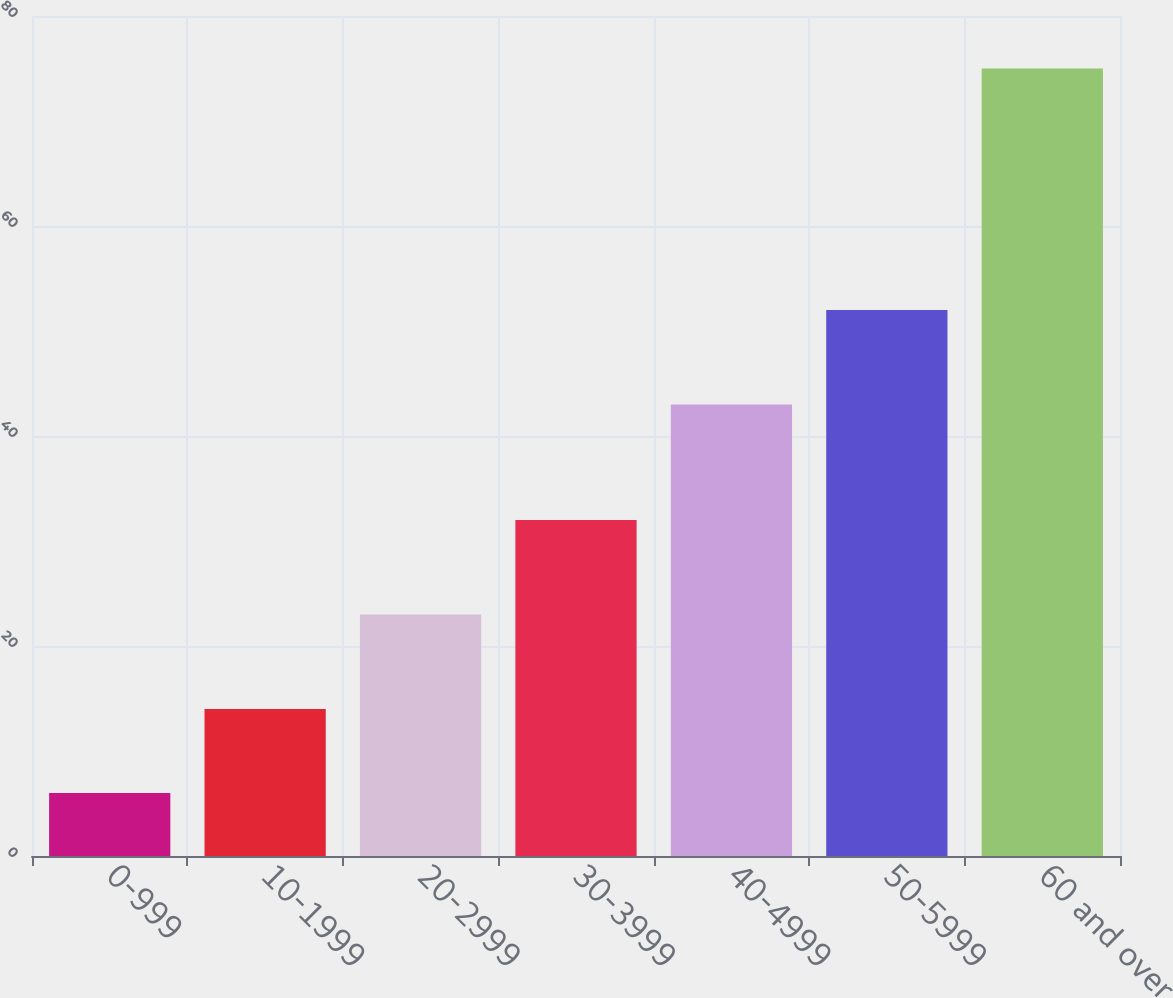Convert chart to OTSL. <chart><loc_0><loc_0><loc_500><loc_500><bar_chart><fcel>0-999<fcel>10-1999<fcel>20-2999<fcel>30-3999<fcel>40-4999<fcel>50-5999<fcel>60 and over<nl><fcel>6<fcel>14<fcel>23<fcel>32<fcel>43<fcel>52<fcel>75<nl></chart> 